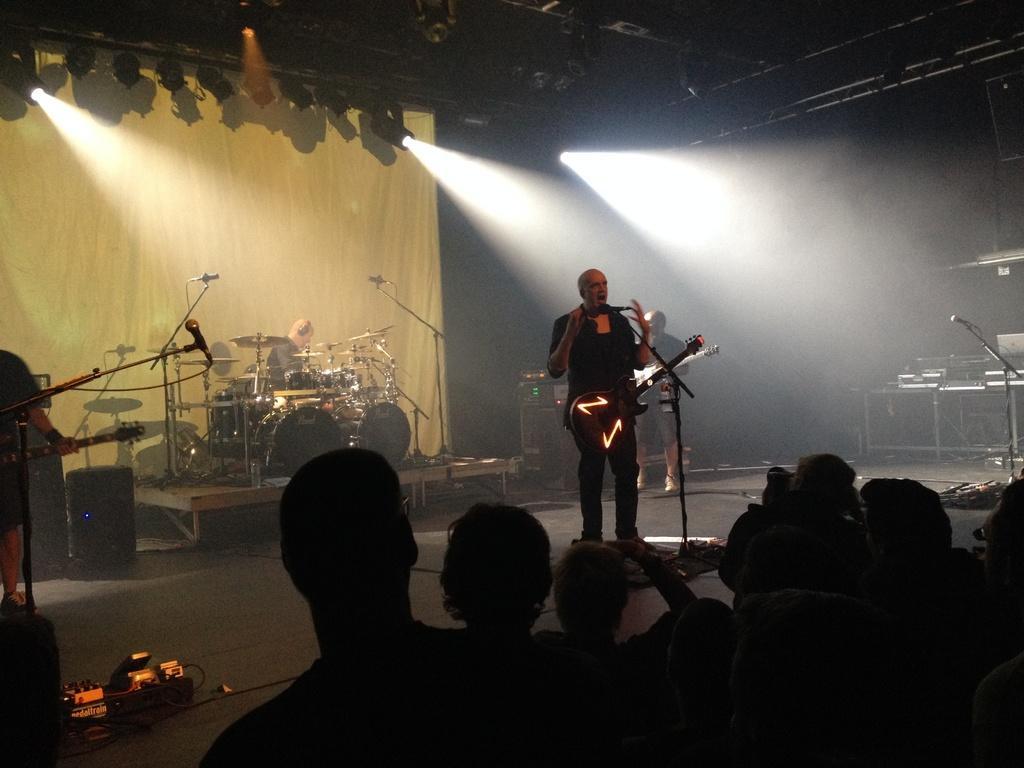Can you describe this image briefly? In this picture we can see a man holding a guitar and playing it behind him there are some musical instruments and some people in front of him. 